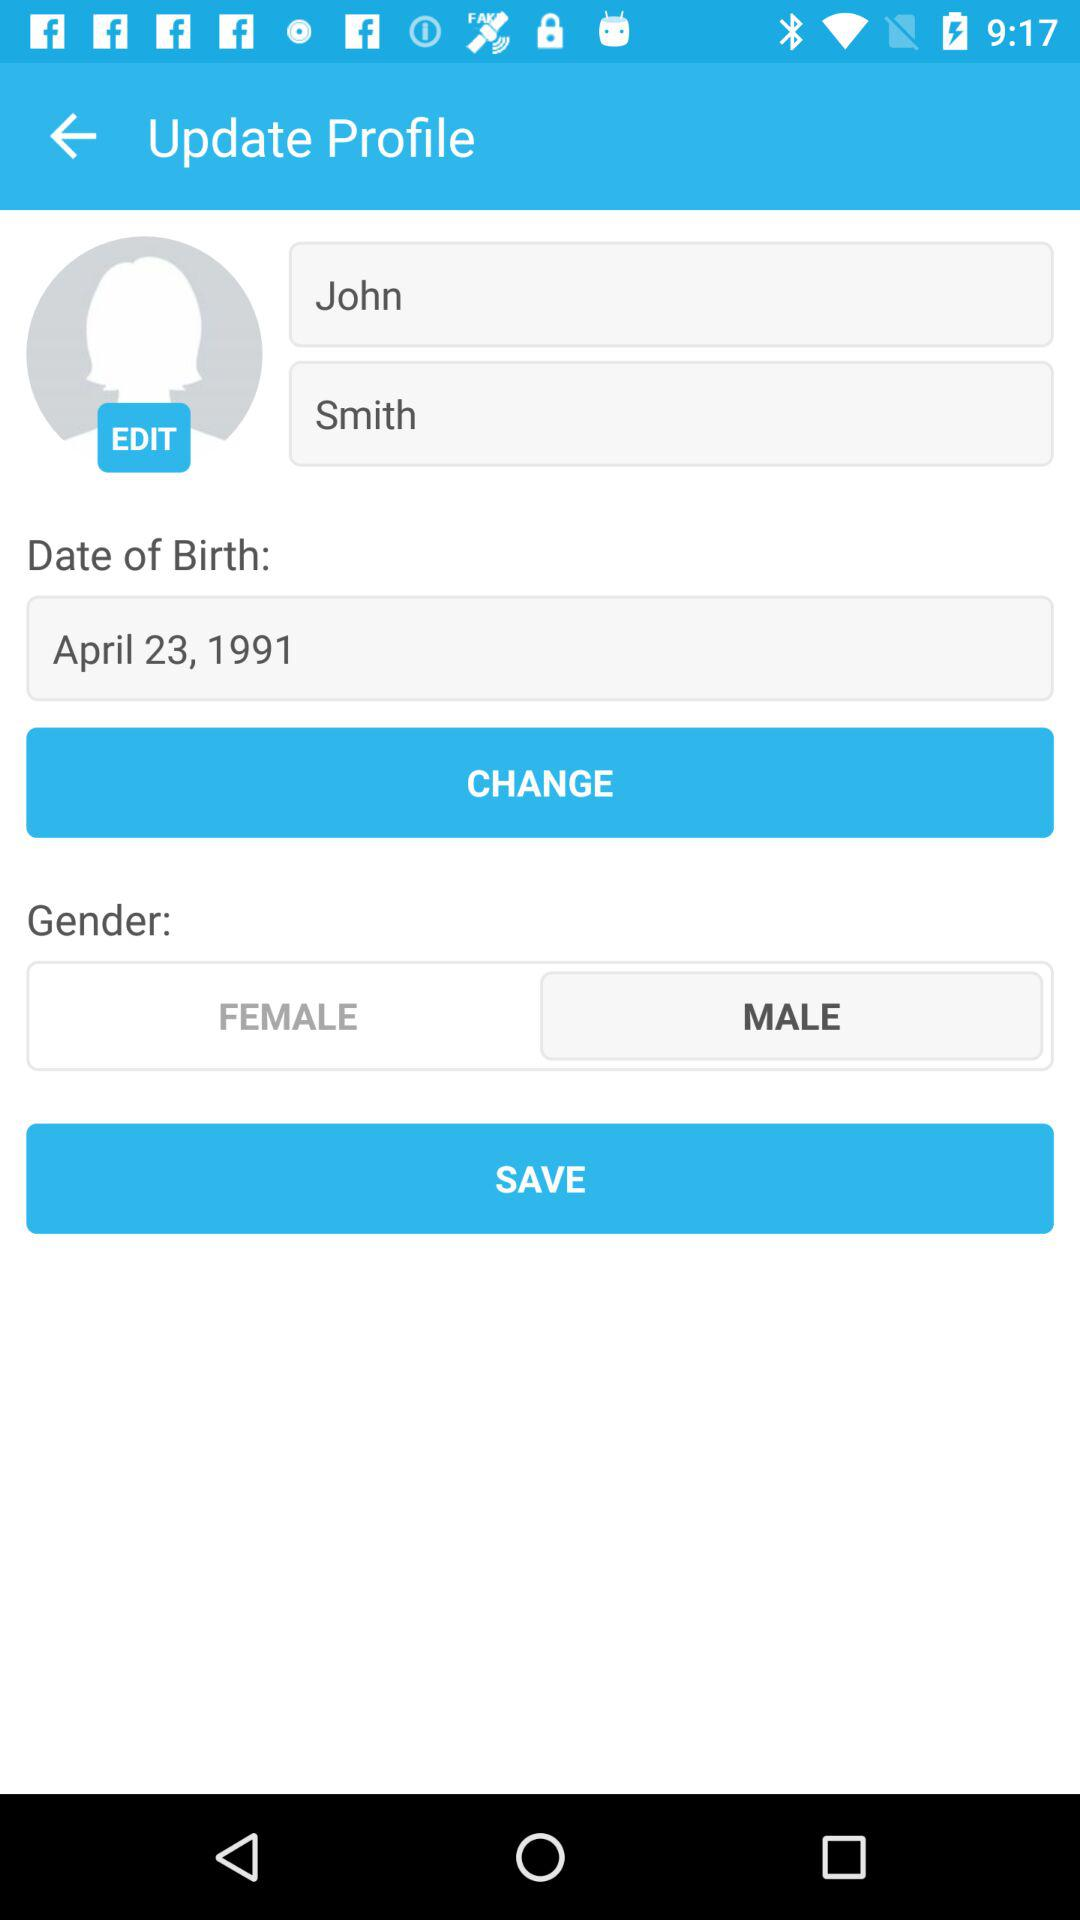What is the gender? The gender is male. 